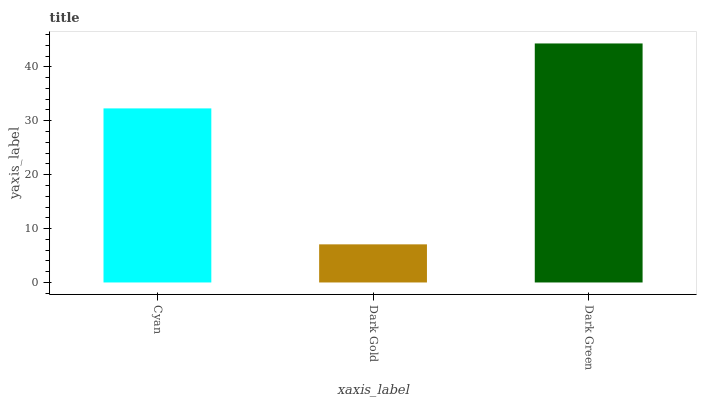Is Dark Gold the minimum?
Answer yes or no. Yes. Is Dark Green the maximum?
Answer yes or no. Yes. Is Dark Green the minimum?
Answer yes or no. No. Is Dark Gold the maximum?
Answer yes or no. No. Is Dark Green greater than Dark Gold?
Answer yes or no. Yes. Is Dark Gold less than Dark Green?
Answer yes or no. Yes. Is Dark Gold greater than Dark Green?
Answer yes or no. No. Is Dark Green less than Dark Gold?
Answer yes or no. No. Is Cyan the high median?
Answer yes or no. Yes. Is Cyan the low median?
Answer yes or no. Yes. Is Dark Green the high median?
Answer yes or no. No. Is Dark Gold the low median?
Answer yes or no. No. 